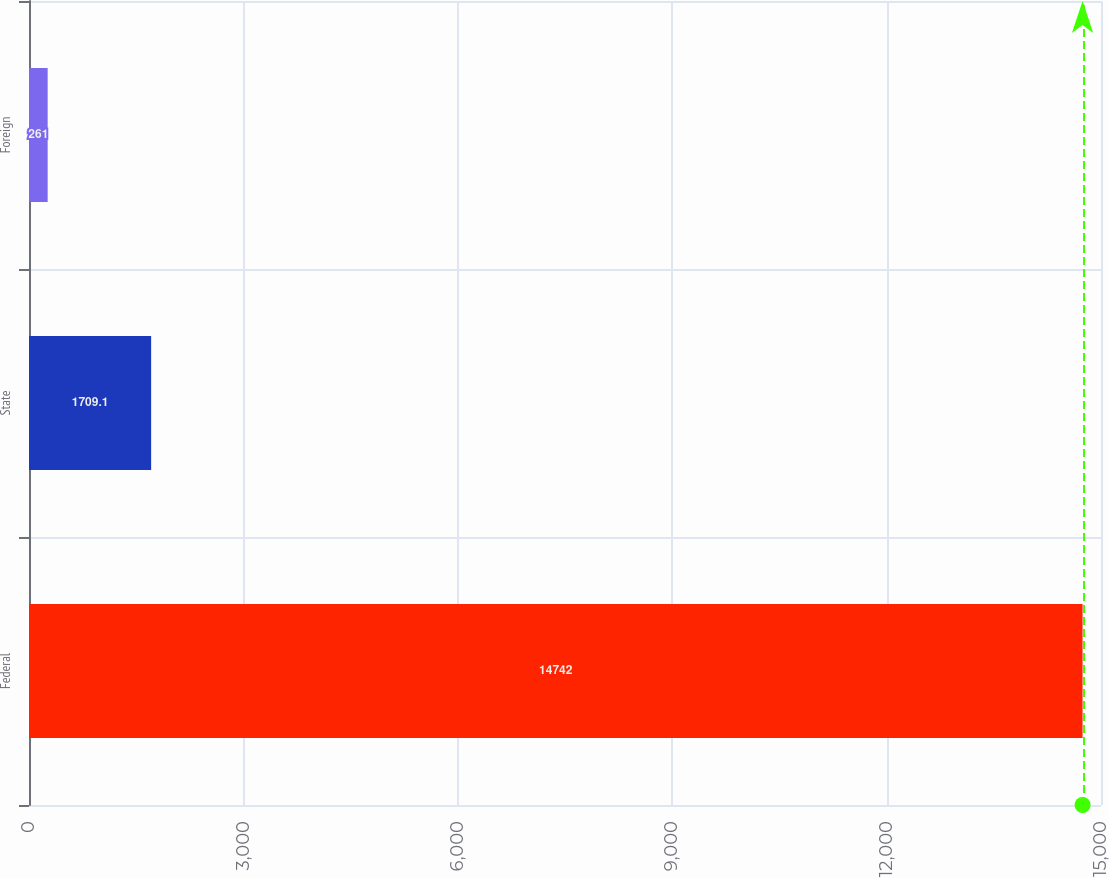Convert chart. <chart><loc_0><loc_0><loc_500><loc_500><bar_chart><fcel>Federal<fcel>State<fcel>Foreign<nl><fcel>14742<fcel>1709.1<fcel>261<nl></chart> 